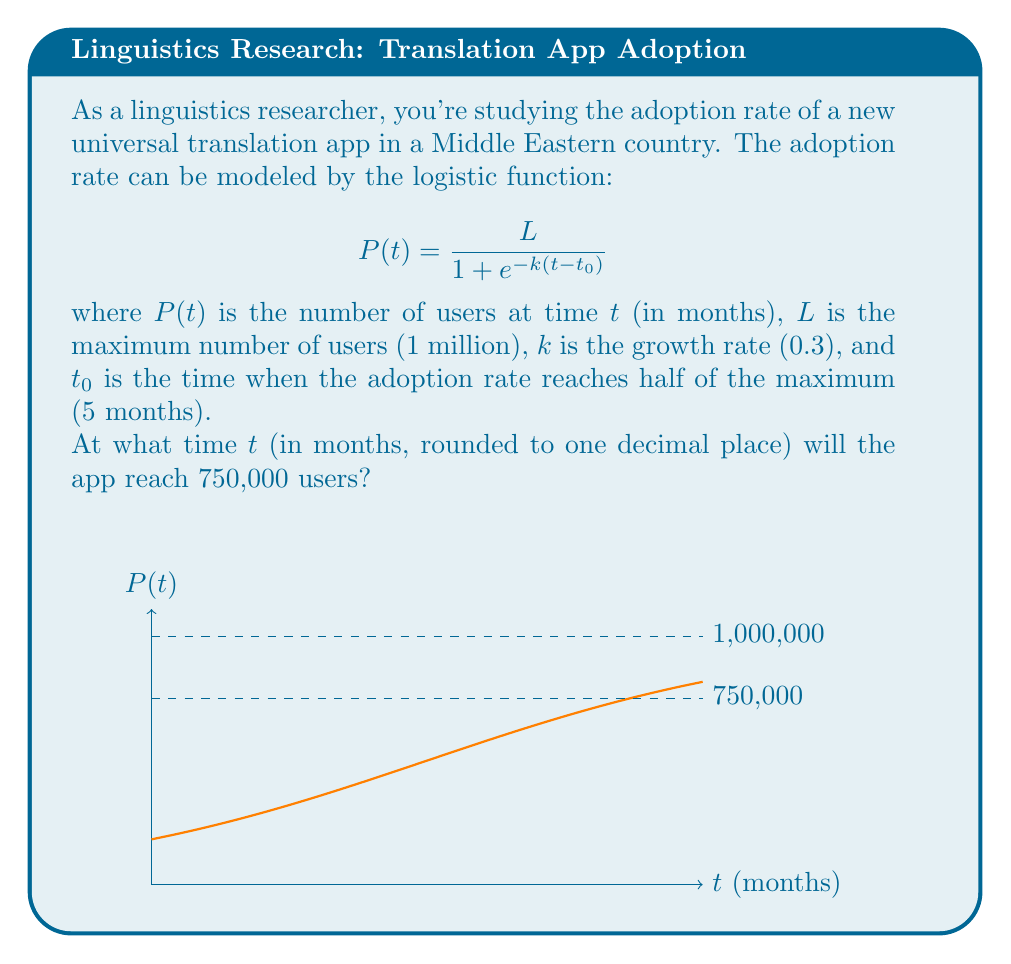What is the answer to this math problem? Let's approach this step-by-step:

1) We're given the logistic function:
   $$P(t) = \frac{L}{1 + e^{-k(t-t_0)}}$$

2) We know the following parameters:
   $L = 1,000,000$ (maximum users)
   $k = 0.3$ (growth rate)
   $t_0 = 5$ (months to reach half of maximum)

3) We want to find $t$ when $P(t) = 750,000$

4) Let's substitute these values into the equation:
   $$750,000 = \frac{1,000,000}{1 + e^{-0.3(t-5)}}$$

5) Simplify:
   $$0.75 = \frac{1}{1 + e^{-0.3(t-5)}}$$

6) Take the reciprocal of both sides:
   $$\frac{4}{3} = 1 + e^{-0.3(t-5)}$$

7) Subtract 1 from both sides:
   $$\frac{1}{3} = e^{-0.3(t-5)}$$

8) Take the natural log of both sides:
   $$\ln(\frac{1}{3}) = -0.3(t-5)$$

9) Solve for $t$:
   $$-1.0986 = -0.3(t-5)$$
   $$3.6620 = t-5$$
   $$t = 8.6620$$

10) Rounding to one decimal place:
    $t ≈ 8.7$ months
Answer: 8.7 months 